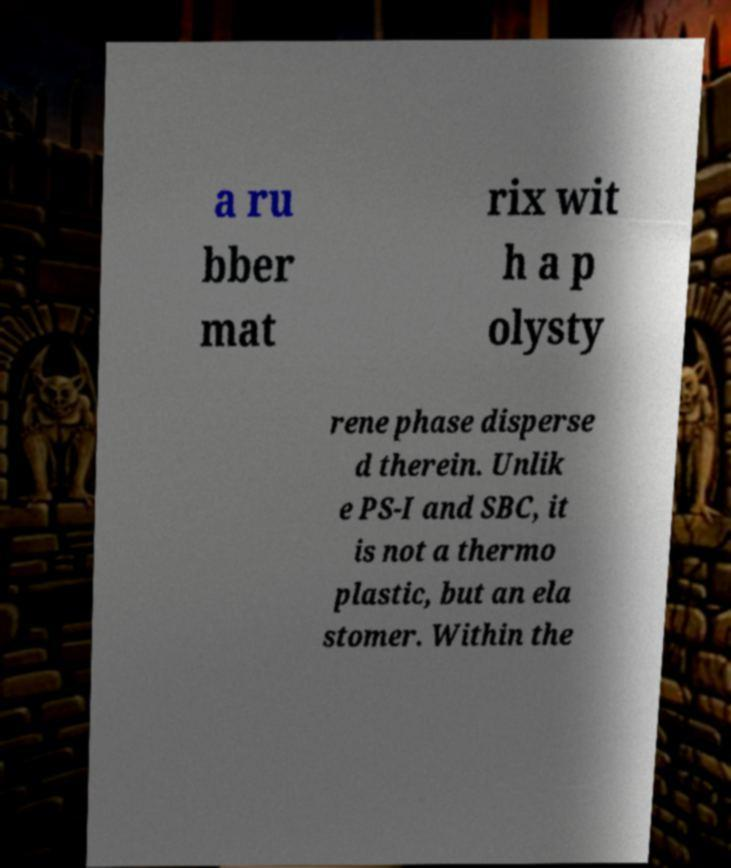Please identify and transcribe the text found in this image. a ru bber mat rix wit h a p olysty rene phase disperse d therein. Unlik e PS-I and SBC, it is not a thermo plastic, but an ela stomer. Within the 